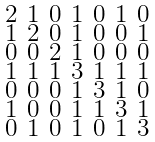Convert formula to latex. <formula><loc_0><loc_0><loc_500><loc_500>\begin{smallmatrix} 2 & 1 & 0 & 1 & 0 & 1 & 0 \\ 1 & 2 & 0 & 1 & 0 & 0 & 1 \\ 0 & 0 & 2 & 1 & 0 & 0 & 0 \\ 1 & 1 & 1 & 3 & 1 & 1 & 1 \\ 0 & 0 & 0 & 1 & 3 & 1 & 0 \\ 1 & 0 & 0 & 1 & 1 & 3 & 1 \\ 0 & 1 & 0 & 1 & 0 & 1 & 3 \end{smallmatrix}</formula> 